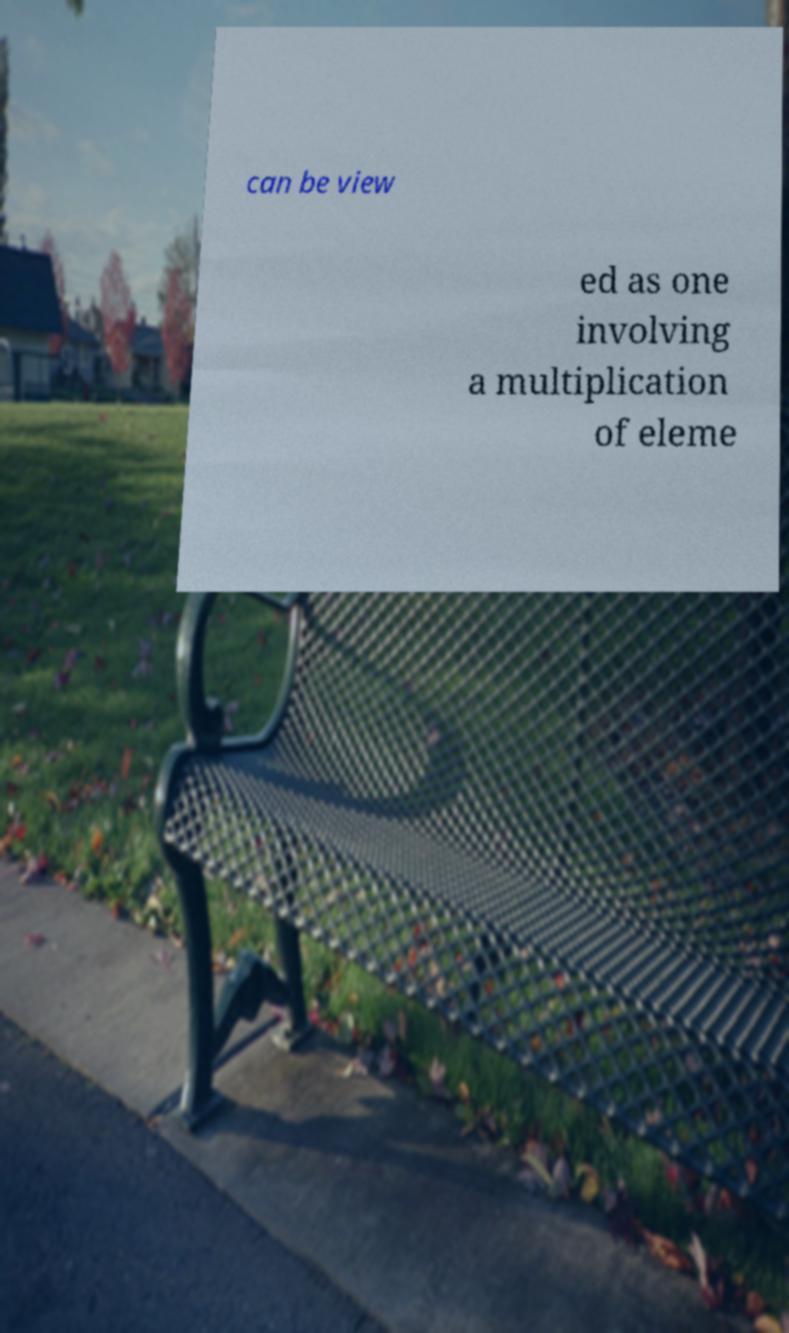There's text embedded in this image that I need extracted. Can you transcribe it verbatim? can be view ed as one involving a multiplication of eleme 